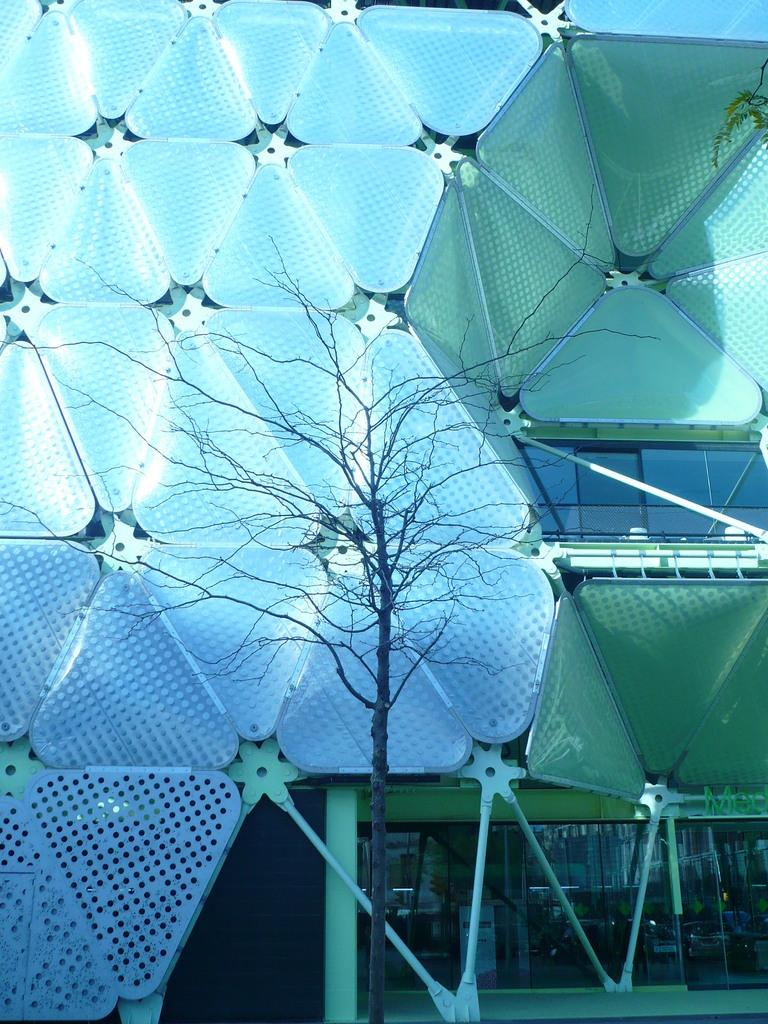What is the main subject in the middle of the picture? There is a tree in the middle of the picture. What is the condition of the tree? The tree is completely dried. What can be seen in the background of the picture? There is a building in the background of the picture. What type of spoon is hanging from the tree in the image? There is no spoon present in the image; it only features a dried tree and a building in the background. 